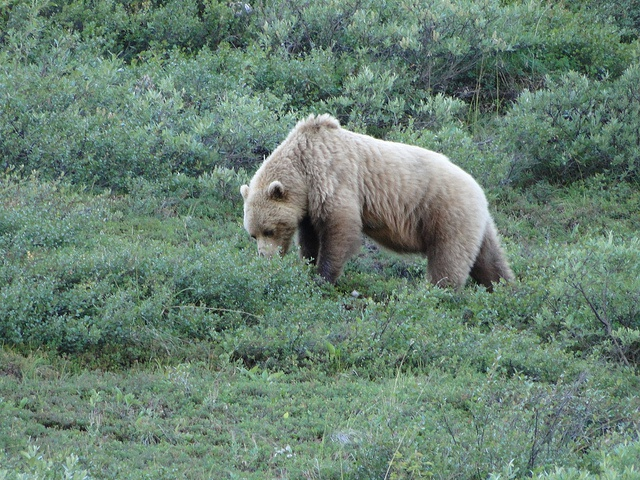Describe the objects in this image and their specific colors. I can see a bear in olive, darkgray, gray, lightgray, and black tones in this image. 